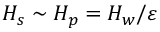<formula> <loc_0><loc_0><loc_500><loc_500>H _ { s } \sim H _ { p } = H _ { w } / { \varepsilon }</formula> 